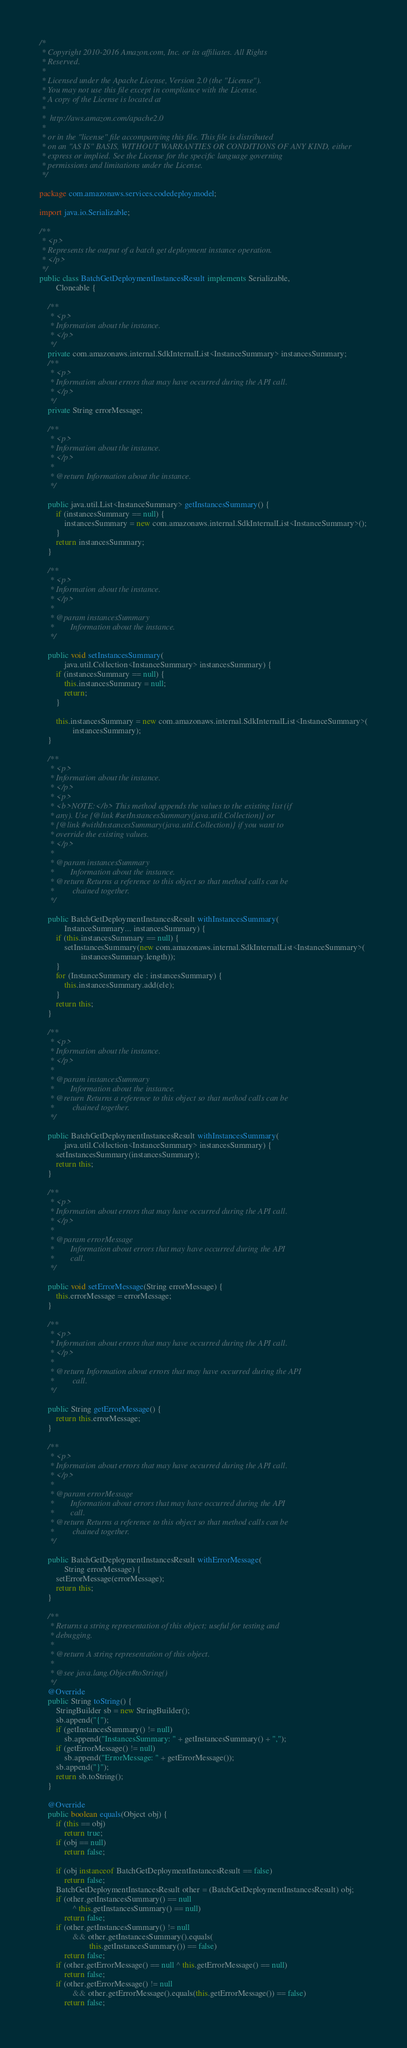Convert code to text. <code><loc_0><loc_0><loc_500><loc_500><_Java_>/*
 * Copyright 2010-2016 Amazon.com, Inc. or its affiliates. All Rights
 * Reserved.
 *
 * Licensed under the Apache License, Version 2.0 (the "License").
 * You may not use this file except in compliance with the License.
 * A copy of the License is located at
 *
 *  http://aws.amazon.com/apache2.0
 *
 * or in the "license" file accompanying this file. This file is distributed
 * on an "AS IS" BASIS, WITHOUT WARRANTIES OR CONDITIONS OF ANY KIND, either
 * express or implied. See the License for the specific language governing
 * permissions and limitations under the License.
 */

package com.amazonaws.services.codedeploy.model;

import java.io.Serializable;

/**
 * <p>
 * Represents the output of a batch get deployment instance operation.
 * </p>
 */
public class BatchGetDeploymentInstancesResult implements Serializable,
        Cloneable {

    /**
     * <p>
     * Information about the instance.
     * </p>
     */
    private com.amazonaws.internal.SdkInternalList<InstanceSummary> instancesSummary;
    /**
     * <p>
     * Information about errors that may have occurred during the API call.
     * </p>
     */
    private String errorMessage;

    /**
     * <p>
     * Information about the instance.
     * </p>
     * 
     * @return Information about the instance.
     */

    public java.util.List<InstanceSummary> getInstancesSummary() {
        if (instancesSummary == null) {
            instancesSummary = new com.amazonaws.internal.SdkInternalList<InstanceSummary>();
        }
        return instancesSummary;
    }

    /**
     * <p>
     * Information about the instance.
     * </p>
     * 
     * @param instancesSummary
     *        Information about the instance.
     */

    public void setInstancesSummary(
            java.util.Collection<InstanceSummary> instancesSummary) {
        if (instancesSummary == null) {
            this.instancesSummary = null;
            return;
        }

        this.instancesSummary = new com.amazonaws.internal.SdkInternalList<InstanceSummary>(
                instancesSummary);
    }

    /**
     * <p>
     * Information about the instance.
     * </p>
     * <p>
     * <b>NOTE:</b> This method appends the values to the existing list (if
     * any). Use {@link #setInstancesSummary(java.util.Collection)} or
     * {@link #withInstancesSummary(java.util.Collection)} if you want to
     * override the existing values.
     * </p>
     * 
     * @param instancesSummary
     *        Information about the instance.
     * @return Returns a reference to this object so that method calls can be
     *         chained together.
     */

    public BatchGetDeploymentInstancesResult withInstancesSummary(
            InstanceSummary... instancesSummary) {
        if (this.instancesSummary == null) {
            setInstancesSummary(new com.amazonaws.internal.SdkInternalList<InstanceSummary>(
                    instancesSummary.length));
        }
        for (InstanceSummary ele : instancesSummary) {
            this.instancesSummary.add(ele);
        }
        return this;
    }

    /**
     * <p>
     * Information about the instance.
     * </p>
     * 
     * @param instancesSummary
     *        Information about the instance.
     * @return Returns a reference to this object so that method calls can be
     *         chained together.
     */

    public BatchGetDeploymentInstancesResult withInstancesSummary(
            java.util.Collection<InstanceSummary> instancesSummary) {
        setInstancesSummary(instancesSummary);
        return this;
    }

    /**
     * <p>
     * Information about errors that may have occurred during the API call.
     * </p>
     * 
     * @param errorMessage
     *        Information about errors that may have occurred during the API
     *        call.
     */

    public void setErrorMessage(String errorMessage) {
        this.errorMessage = errorMessage;
    }

    /**
     * <p>
     * Information about errors that may have occurred during the API call.
     * </p>
     * 
     * @return Information about errors that may have occurred during the API
     *         call.
     */

    public String getErrorMessage() {
        return this.errorMessage;
    }

    /**
     * <p>
     * Information about errors that may have occurred during the API call.
     * </p>
     * 
     * @param errorMessage
     *        Information about errors that may have occurred during the API
     *        call.
     * @return Returns a reference to this object so that method calls can be
     *         chained together.
     */

    public BatchGetDeploymentInstancesResult withErrorMessage(
            String errorMessage) {
        setErrorMessage(errorMessage);
        return this;
    }

    /**
     * Returns a string representation of this object; useful for testing and
     * debugging.
     *
     * @return A string representation of this object.
     *
     * @see java.lang.Object#toString()
     */
    @Override
    public String toString() {
        StringBuilder sb = new StringBuilder();
        sb.append("{");
        if (getInstancesSummary() != null)
            sb.append("InstancesSummary: " + getInstancesSummary() + ",");
        if (getErrorMessage() != null)
            sb.append("ErrorMessage: " + getErrorMessage());
        sb.append("}");
        return sb.toString();
    }

    @Override
    public boolean equals(Object obj) {
        if (this == obj)
            return true;
        if (obj == null)
            return false;

        if (obj instanceof BatchGetDeploymentInstancesResult == false)
            return false;
        BatchGetDeploymentInstancesResult other = (BatchGetDeploymentInstancesResult) obj;
        if (other.getInstancesSummary() == null
                ^ this.getInstancesSummary() == null)
            return false;
        if (other.getInstancesSummary() != null
                && other.getInstancesSummary().equals(
                        this.getInstancesSummary()) == false)
            return false;
        if (other.getErrorMessage() == null ^ this.getErrorMessage() == null)
            return false;
        if (other.getErrorMessage() != null
                && other.getErrorMessage().equals(this.getErrorMessage()) == false)
            return false;</code> 